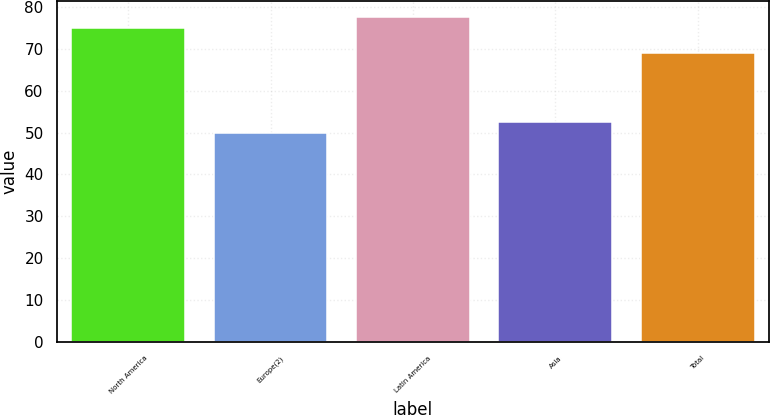<chart> <loc_0><loc_0><loc_500><loc_500><bar_chart><fcel>North America<fcel>Europe(2)<fcel>Latin America<fcel>Asia<fcel>Total<nl><fcel>75<fcel>50<fcel>77.6<fcel>52.6<fcel>69<nl></chart> 